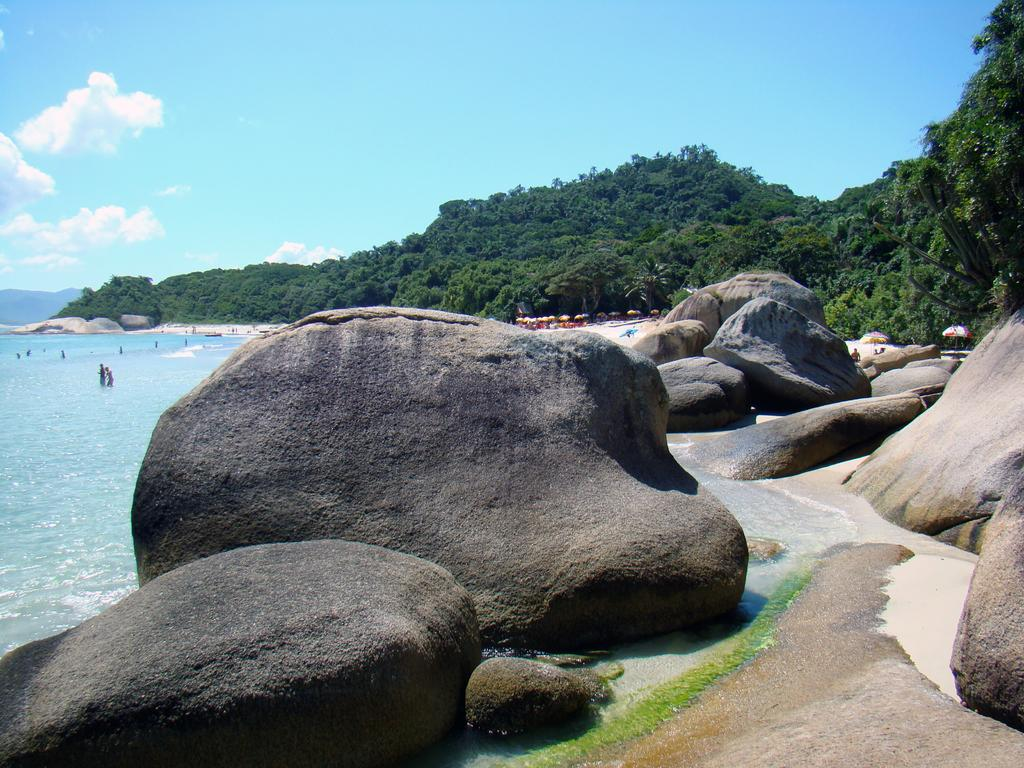What type of natural elements can be seen in the image? There are rocks and water visible in the image. What can be seen in the background of the image? There are people, trees, and the sky visible in the background of the image. What is the condition of the sky in the image? Clouds are present in the sky in the image. How many crackers are being used in the competition shown in the image? There is no competition or crackers present in the image. What number is associated with the rocks in the image? There is no specific number associated with the rocks in the image; they are simply visible as a natural element. 